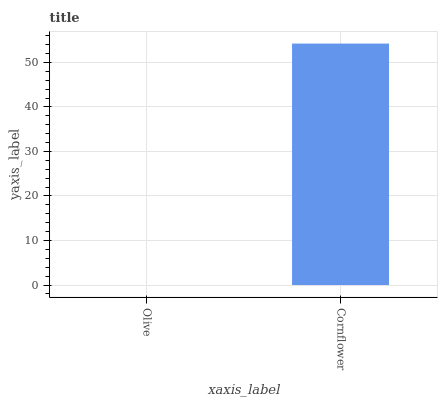Is Olive the minimum?
Answer yes or no. Yes. Is Cornflower the maximum?
Answer yes or no. Yes. Is Cornflower the minimum?
Answer yes or no. No. Is Cornflower greater than Olive?
Answer yes or no. Yes. Is Olive less than Cornflower?
Answer yes or no. Yes. Is Olive greater than Cornflower?
Answer yes or no. No. Is Cornflower less than Olive?
Answer yes or no. No. Is Cornflower the high median?
Answer yes or no. Yes. Is Olive the low median?
Answer yes or no. Yes. Is Olive the high median?
Answer yes or no. No. Is Cornflower the low median?
Answer yes or no. No. 